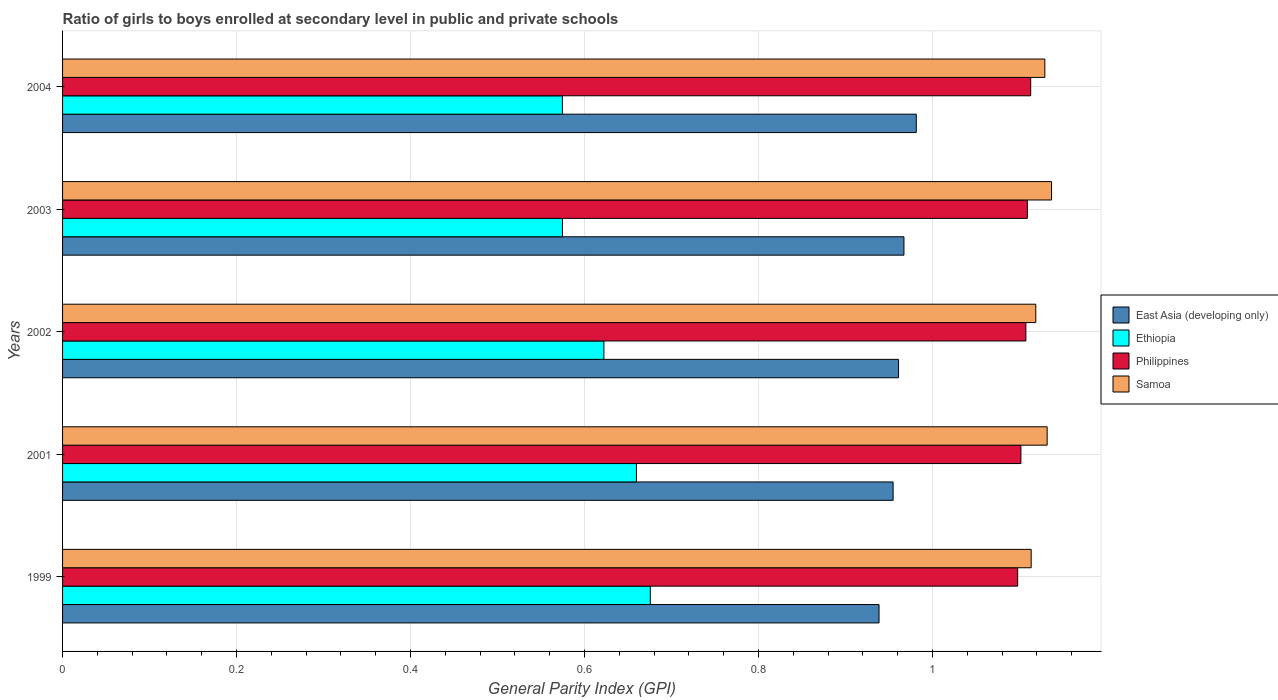Are the number of bars per tick equal to the number of legend labels?
Provide a short and direct response. Yes. How many bars are there on the 3rd tick from the top?
Give a very brief answer. 4. How many bars are there on the 5th tick from the bottom?
Make the answer very short. 4. What is the general parity index in Philippines in 2001?
Provide a short and direct response. 1.1. Across all years, what is the maximum general parity index in East Asia (developing only)?
Give a very brief answer. 0.98. Across all years, what is the minimum general parity index in Samoa?
Offer a very short reply. 1.11. In which year was the general parity index in Samoa maximum?
Make the answer very short. 2003. In which year was the general parity index in Philippines minimum?
Ensure brevity in your answer.  1999. What is the total general parity index in East Asia (developing only) in the graph?
Your answer should be compact. 4.8. What is the difference between the general parity index in Philippines in 1999 and that in 2002?
Your answer should be compact. -0.01. What is the difference between the general parity index in Ethiopia in 2004 and the general parity index in Samoa in 1999?
Make the answer very short. -0.54. What is the average general parity index in Ethiopia per year?
Provide a succinct answer. 0.62. In the year 2003, what is the difference between the general parity index in East Asia (developing only) and general parity index in Philippines?
Provide a short and direct response. -0.14. What is the ratio of the general parity index in Ethiopia in 2002 to that in 2003?
Your answer should be compact. 1.08. What is the difference between the highest and the second highest general parity index in East Asia (developing only)?
Make the answer very short. 0.01. What is the difference between the highest and the lowest general parity index in East Asia (developing only)?
Offer a very short reply. 0.04. In how many years, is the general parity index in East Asia (developing only) greater than the average general parity index in East Asia (developing only) taken over all years?
Your answer should be compact. 3. Is the sum of the general parity index in Samoa in 2003 and 2004 greater than the maximum general parity index in Ethiopia across all years?
Provide a succinct answer. Yes. Is it the case that in every year, the sum of the general parity index in Ethiopia and general parity index in Samoa is greater than the sum of general parity index in Philippines and general parity index in East Asia (developing only)?
Offer a very short reply. No. What does the 3rd bar from the top in 2002 represents?
Offer a terse response. Ethiopia. What does the 2nd bar from the bottom in 2002 represents?
Offer a terse response. Ethiopia. Is it the case that in every year, the sum of the general parity index in Ethiopia and general parity index in Philippines is greater than the general parity index in Samoa?
Provide a succinct answer. Yes. How many years are there in the graph?
Keep it short and to the point. 5. Are the values on the major ticks of X-axis written in scientific E-notation?
Keep it short and to the point. No. Does the graph contain any zero values?
Offer a terse response. No. How many legend labels are there?
Offer a very short reply. 4. How are the legend labels stacked?
Make the answer very short. Vertical. What is the title of the graph?
Give a very brief answer. Ratio of girls to boys enrolled at secondary level in public and private schools. Does "Heavily indebted poor countries" appear as one of the legend labels in the graph?
Provide a succinct answer. No. What is the label or title of the X-axis?
Give a very brief answer. General Parity Index (GPI). What is the General Parity Index (GPI) in East Asia (developing only) in 1999?
Provide a succinct answer. 0.94. What is the General Parity Index (GPI) in Ethiopia in 1999?
Offer a very short reply. 0.68. What is the General Parity Index (GPI) in Philippines in 1999?
Offer a terse response. 1.1. What is the General Parity Index (GPI) of Samoa in 1999?
Keep it short and to the point. 1.11. What is the General Parity Index (GPI) in East Asia (developing only) in 2001?
Give a very brief answer. 0.95. What is the General Parity Index (GPI) of Ethiopia in 2001?
Ensure brevity in your answer.  0.66. What is the General Parity Index (GPI) of Philippines in 2001?
Provide a short and direct response. 1.1. What is the General Parity Index (GPI) in Samoa in 2001?
Your answer should be very brief. 1.13. What is the General Parity Index (GPI) in East Asia (developing only) in 2002?
Keep it short and to the point. 0.96. What is the General Parity Index (GPI) of Ethiopia in 2002?
Offer a very short reply. 0.62. What is the General Parity Index (GPI) in Philippines in 2002?
Offer a terse response. 1.11. What is the General Parity Index (GPI) in Samoa in 2002?
Provide a succinct answer. 1.12. What is the General Parity Index (GPI) of East Asia (developing only) in 2003?
Keep it short and to the point. 0.97. What is the General Parity Index (GPI) of Ethiopia in 2003?
Give a very brief answer. 0.57. What is the General Parity Index (GPI) of Philippines in 2003?
Offer a terse response. 1.11. What is the General Parity Index (GPI) in Samoa in 2003?
Provide a succinct answer. 1.14. What is the General Parity Index (GPI) in East Asia (developing only) in 2004?
Your answer should be very brief. 0.98. What is the General Parity Index (GPI) in Ethiopia in 2004?
Ensure brevity in your answer.  0.57. What is the General Parity Index (GPI) of Philippines in 2004?
Provide a short and direct response. 1.11. What is the General Parity Index (GPI) of Samoa in 2004?
Give a very brief answer. 1.13. Across all years, what is the maximum General Parity Index (GPI) in East Asia (developing only)?
Your answer should be compact. 0.98. Across all years, what is the maximum General Parity Index (GPI) in Ethiopia?
Your answer should be compact. 0.68. Across all years, what is the maximum General Parity Index (GPI) of Philippines?
Make the answer very short. 1.11. Across all years, what is the maximum General Parity Index (GPI) in Samoa?
Ensure brevity in your answer.  1.14. Across all years, what is the minimum General Parity Index (GPI) of East Asia (developing only)?
Give a very brief answer. 0.94. Across all years, what is the minimum General Parity Index (GPI) of Ethiopia?
Offer a terse response. 0.57. Across all years, what is the minimum General Parity Index (GPI) in Philippines?
Your response must be concise. 1.1. Across all years, what is the minimum General Parity Index (GPI) of Samoa?
Offer a terse response. 1.11. What is the total General Parity Index (GPI) in East Asia (developing only) in the graph?
Give a very brief answer. 4.8. What is the total General Parity Index (GPI) in Ethiopia in the graph?
Give a very brief answer. 3.11. What is the total General Parity Index (GPI) in Philippines in the graph?
Offer a very short reply. 5.53. What is the total General Parity Index (GPI) in Samoa in the graph?
Offer a terse response. 5.63. What is the difference between the General Parity Index (GPI) in East Asia (developing only) in 1999 and that in 2001?
Provide a short and direct response. -0.02. What is the difference between the General Parity Index (GPI) in Ethiopia in 1999 and that in 2001?
Offer a very short reply. 0.02. What is the difference between the General Parity Index (GPI) of Philippines in 1999 and that in 2001?
Keep it short and to the point. -0. What is the difference between the General Parity Index (GPI) in Samoa in 1999 and that in 2001?
Your response must be concise. -0.02. What is the difference between the General Parity Index (GPI) of East Asia (developing only) in 1999 and that in 2002?
Your response must be concise. -0.02. What is the difference between the General Parity Index (GPI) of Ethiopia in 1999 and that in 2002?
Offer a very short reply. 0.05. What is the difference between the General Parity Index (GPI) in Philippines in 1999 and that in 2002?
Provide a succinct answer. -0.01. What is the difference between the General Parity Index (GPI) in Samoa in 1999 and that in 2002?
Give a very brief answer. -0.01. What is the difference between the General Parity Index (GPI) of East Asia (developing only) in 1999 and that in 2003?
Your answer should be very brief. -0.03. What is the difference between the General Parity Index (GPI) of Ethiopia in 1999 and that in 2003?
Offer a terse response. 0.1. What is the difference between the General Parity Index (GPI) of Philippines in 1999 and that in 2003?
Your response must be concise. -0.01. What is the difference between the General Parity Index (GPI) of Samoa in 1999 and that in 2003?
Make the answer very short. -0.02. What is the difference between the General Parity Index (GPI) in East Asia (developing only) in 1999 and that in 2004?
Ensure brevity in your answer.  -0.04. What is the difference between the General Parity Index (GPI) in Ethiopia in 1999 and that in 2004?
Provide a succinct answer. 0.1. What is the difference between the General Parity Index (GPI) of Philippines in 1999 and that in 2004?
Keep it short and to the point. -0.01. What is the difference between the General Parity Index (GPI) of Samoa in 1999 and that in 2004?
Ensure brevity in your answer.  -0.02. What is the difference between the General Parity Index (GPI) of East Asia (developing only) in 2001 and that in 2002?
Make the answer very short. -0.01. What is the difference between the General Parity Index (GPI) of Ethiopia in 2001 and that in 2002?
Make the answer very short. 0.04. What is the difference between the General Parity Index (GPI) of Philippines in 2001 and that in 2002?
Your answer should be very brief. -0.01. What is the difference between the General Parity Index (GPI) in Samoa in 2001 and that in 2002?
Your answer should be very brief. 0.01. What is the difference between the General Parity Index (GPI) of East Asia (developing only) in 2001 and that in 2003?
Ensure brevity in your answer.  -0.01. What is the difference between the General Parity Index (GPI) in Ethiopia in 2001 and that in 2003?
Offer a terse response. 0.09. What is the difference between the General Parity Index (GPI) in Philippines in 2001 and that in 2003?
Provide a short and direct response. -0.01. What is the difference between the General Parity Index (GPI) in Samoa in 2001 and that in 2003?
Offer a terse response. -0.01. What is the difference between the General Parity Index (GPI) in East Asia (developing only) in 2001 and that in 2004?
Provide a short and direct response. -0.03. What is the difference between the General Parity Index (GPI) of Ethiopia in 2001 and that in 2004?
Ensure brevity in your answer.  0.09. What is the difference between the General Parity Index (GPI) of Philippines in 2001 and that in 2004?
Keep it short and to the point. -0.01. What is the difference between the General Parity Index (GPI) in Samoa in 2001 and that in 2004?
Provide a succinct answer. 0. What is the difference between the General Parity Index (GPI) in East Asia (developing only) in 2002 and that in 2003?
Make the answer very short. -0.01. What is the difference between the General Parity Index (GPI) in Ethiopia in 2002 and that in 2003?
Keep it short and to the point. 0.05. What is the difference between the General Parity Index (GPI) in Philippines in 2002 and that in 2003?
Make the answer very short. -0. What is the difference between the General Parity Index (GPI) in Samoa in 2002 and that in 2003?
Your response must be concise. -0.02. What is the difference between the General Parity Index (GPI) in East Asia (developing only) in 2002 and that in 2004?
Provide a short and direct response. -0.02. What is the difference between the General Parity Index (GPI) in Ethiopia in 2002 and that in 2004?
Offer a very short reply. 0.05. What is the difference between the General Parity Index (GPI) of Philippines in 2002 and that in 2004?
Your response must be concise. -0.01. What is the difference between the General Parity Index (GPI) of Samoa in 2002 and that in 2004?
Keep it short and to the point. -0.01. What is the difference between the General Parity Index (GPI) in East Asia (developing only) in 2003 and that in 2004?
Make the answer very short. -0.01. What is the difference between the General Parity Index (GPI) of Ethiopia in 2003 and that in 2004?
Your response must be concise. 0. What is the difference between the General Parity Index (GPI) of Philippines in 2003 and that in 2004?
Offer a very short reply. -0. What is the difference between the General Parity Index (GPI) of Samoa in 2003 and that in 2004?
Your response must be concise. 0.01. What is the difference between the General Parity Index (GPI) of East Asia (developing only) in 1999 and the General Parity Index (GPI) of Ethiopia in 2001?
Ensure brevity in your answer.  0.28. What is the difference between the General Parity Index (GPI) of East Asia (developing only) in 1999 and the General Parity Index (GPI) of Philippines in 2001?
Your response must be concise. -0.16. What is the difference between the General Parity Index (GPI) of East Asia (developing only) in 1999 and the General Parity Index (GPI) of Samoa in 2001?
Ensure brevity in your answer.  -0.19. What is the difference between the General Parity Index (GPI) of Ethiopia in 1999 and the General Parity Index (GPI) of Philippines in 2001?
Make the answer very short. -0.43. What is the difference between the General Parity Index (GPI) of Ethiopia in 1999 and the General Parity Index (GPI) of Samoa in 2001?
Provide a succinct answer. -0.46. What is the difference between the General Parity Index (GPI) of Philippines in 1999 and the General Parity Index (GPI) of Samoa in 2001?
Provide a short and direct response. -0.03. What is the difference between the General Parity Index (GPI) in East Asia (developing only) in 1999 and the General Parity Index (GPI) in Ethiopia in 2002?
Provide a succinct answer. 0.32. What is the difference between the General Parity Index (GPI) in East Asia (developing only) in 1999 and the General Parity Index (GPI) in Philippines in 2002?
Make the answer very short. -0.17. What is the difference between the General Parity Index (GPI) in East Asia (developing only) in 1999 and the General Parity Index (GPI) in Samoa in 2002?
Your answer should be very brief. -0.18. What is the difference between the General Parity Index (GPI) in Ethiopia in 1999 and the General Parity Index (GPI) in Philippines in 2002?
Offer a very short reply. -0.43. What is the difference between the General Parity Index (GPI) in Ethiopia in 1999 and the General Parity Index (GPI) in Samoa in 2002?
Make the answer very short. -0.44. What is the difference between the General Parity Index (GPI) in Philippines in 1999 and the General Parity Index (GPI) in Samoa in 2002?
Give a very brief answer. -0.02. What is the difference between the General Parity Index (GPI) of East Asia (developing only) in 1999 and the General Parity Index (GPI) of Ethiopia in 2003?
Ensure brevity in your answer.  0.36. What is the difference between the General Parity Index (GPI) of East Asia (developing only) in 1999 and the General Parity Index (GPI) of Philippines in 2003?
Give a very brief answer. -0.17. What is the difference between the General Parity Index (GPI) of East Asia (developing only) in 1999 and the General Parity Index (GPI) of Samoa in 2003?
Your answer should be very brief. -0.2. What is the difference between the General Parity Index (GPI) of Ethiopia in 1999 and the General Parity Index (GPI) of Philippines in 2003?
Make the answer very short. -0.43. What is the difference between the General Parity Index (GPI) in Ethiopia in 1999 and the General Parity Index (GPI) in Samoa in 2003?
Ensure brevity in your answer.  -0.46. What is the difference between the General Parity Index (GPI) in Philippines in 1999 and the General Parity Index (GPI) in Samoa in 2003?
Make the answer very short. -0.04. What is the difference between the General Parity Index (GPI) of East Asia (developing only) in 1999 and the General Parity Index (GPI) of Ethiopia in 2004?
Your answer should be very brief. 0.36. What is the difference between the General Parity Index (GPI) in East Asia (developing only) in 1999 and the General Parity Index (GPI) in Philippines in 2004?
Your answer should be very brief. -0.17. What is the difference between the General Parity Index (GPI) of East Asia (developing only) in 1999 and the General Parity Index (GPI) of Samoa in 2004?
Offer a very short reply. -0.19. What is the difference between the General Parity Index (GPI) of Ethiopia in 1999 and the General Parity Index (GPI) of Philippines in 2004?
Offer a terse response. -0.44. What is the difference between the General Parity Index (GPI) of Ethiopia in 1999 and the General Parity Index (GPI) of Samoa in 2004?
Give a very brief answer. -0.45. What is the difference between the General Parity Index (GPI) in Philippines in 1999 and the General Parity Index (GPI) in Samoa in 2004?
Your response must be concise. -0.03. What is the difference between the General Parity Index (GPI) of East Asia (developing only) in 2001 and the General Parity Index (GPI) of Ethiopia in 2002?
Provide a succinct answer. 0.33. What is the difference between the General Parity Index (GPI) of East Asia (developing only) in 2001 and the General Parity Index (GPI) of Philippines in 2002?
Ensure brevity in your answer.  -0.15. What is the difference between the General Parity Index (GPI) of East Asia (developing only) in 2001 and the General Parity Index (GPI) of Samoa in 2002?
Offer a terse response. -0.16. What is the difference between the General Parity Index (GPI) of Ethiopia in 2001 and the General Parity Index (GPI) of Philippines in 2002?
Provide a short and direct response. -0.45. What is the difference between the General Parity Index (GPI) of Ethiopia in 2001 and the General Parity Index (GPI) of Samoa in 2002?
Ensure brevity in your answer.  -0.46. What is the difference between the General Parity Index (GPI) of Philippines in 2001 and the General Parity Index (GPI) of Samoa in 2002?
Give a very brief answer. -0.02. What is the difference between the General Parity Index (GPI) in East Asia (developing only) in 2001 and the General Parity Index (GPI) in Ethiopia in 2003?
Give a very brief answer. 0.38. What is the difference between the General Parity Index (GPI) in East Asia (developing only) in 2001 and the General Parity Index (GPI) in Philippines in 2003?
Ensure brevity in your answer.  -0.15. What is the difference between the General Parity Index (GPI) of East Asia (developing only) in 2001 and the General Parity Index (GPI) of Samoa in 2003?
Your answer should be compact. -0.18. What is the difference between the General Parity Index (GPI) in Ethiopia in 2001 and the General Parity Index (GPI) in Philippines in 2003?
Offer a very short reply. -0.45. What is the difference between the General Parity Index (GPI) in Ethiopia in 2001 and the General Parity Index (GPI) in Samoa in 2003?
Ensure brevity in your answer.  -0.48. What is the difference between the General Parity Index (GPI) in Philippines in 2001 and the General Parity Index (GPI) in Samoa in 2003?
Offer a terse response. -0.04. What is the difference between the General Parity Index (GPI) in East Asia (developing only) in 2001 and the General Parity Index (GPI) in Ethiopia in 2004?
Offer a terse response. 0.38. What is the difference between the General Parity Index (GPI) of East Asia (developing only) in 2001 and the General Parity Index (GPI) of Philippines in 2004?
Your response must be concise. -0.16. What is the difference between the General Parity Index (GPI) in East Asia (developing only) in 2001 and the General Parity Index (GPI) in Samoa in 2004?
Give a very brief answer. -0.17. What is the difference between the General Parity Index (GPI) of Ethiopia in 2001 and the General Parity Index (GPI) of Philippines in 2004?
Provide a succinct answer. -0.45. What is the difference between the General Parity Index (GPI) in Ethiopia in 2001 and the General Parity Index (GPI) in Samoa in 2004?
Your answer should be compact. -0.47. What is the difference between the General Parity Index (GPI) in Philippines in 2001 and the General Parity Index (GPI) in Samoa in 2004?
Ensure brevity in your answer.  -0.03. What is the difference between the General Parity Index (GPI) of East Asia (developing only) in 2002 and the General Parity Index (GPI) of Ethiopia in 2003?
Make the answer very short. 0.39. What is the difference between the General Parity Index (GPI) in East Asia (developing only) in 2002 and the General Parity Index (GPI) in Philippines in 2003?
Keep it short and to the point. -0.15. What is the difference between the General Parity Index (GPI) of East Asia (developing only) in 2002 and the General Parity Index (GPI) of Samoa in 2003?
Give a very brief answer. -0.18. What is the difference between the General Parity Index (GPI) in Ethiopia in 2002 and the General Parity Index (GPI) in Philippines in 2003?
Ensure brevity in your answer.  -0.49. What is the difference between the General Parity Index (GPI) of Ethiopia in 2002 and the General Parity Index (GPI) of Samoa in 2003?
Keep it short and to the point. -0.51. What is the difference between the General Parity Index (GPI) of Philippines in 2002 and the General Parity Index (GPI) of Samoa in 2003?
Your response must be concise. -0.03. What is the difference between the General Parity Index (GPI) in East Asia (developing only) in 2002 and the General Parity Index (GPI) in Ethiopia in 2004?
Keep it short and to the point. 0.39. What is the difference between the General Parity Index (GPI) of East Asia (developing only) in 2002 and the General Parity Index (GPI) of Philippines in 2004?
Give a very brief answer. -0.15. What is the difference between the General Parity Index (GPI) in East Asia (developing only) in 2002 and the General Parity Index (GPI) in Samoa in 2004?
Make the answer very short. -0.17. What is the difference between the General Parity Index (GPI) in Ethiopia in 2002 and the General Parity Index (GPI) in Philippines in 2004?
Ensure brevity in your answer.  -0.49. What is the difference between the General Parity Index (GPI) of Ethiopia in 2002 and the General Parity Index (GPI) of Samoa in 2004?
Your answer should be very brief. -0.51. What is the difference between the General Parity Index (GPI) in Philippines in 2002 and the General Parity Index (GPI) in Samoa in 2004?
Make the answer very short. -0.02. What is the difference between the General Parity Index (GPI) in East Asia (developing only) in 2003 and the General Parity Index (GPI) in Ethiopia in 2004?
Make the answer very short. 0.39. What is the difference between the General Parity Index (GPI) in East Asia (developing only) in 2003 and the General Parity Index (GPI) in Philippines in 2004?
Your answer should be very brief. -0.15. What is the difference between the General Parity Index (GPI) in East Asia (developing only) in 2003 and the General Parity Index (GPI) in Samoa in 2004?
Your answer should be compact. -0.16. What is the difference between the General Parity Index (GPI) in Ethiopia in 2003 and the General Parity Index (GPI) in Philippines in 2004?
Your answer should be compact. -0.54. What is the difference between the General Parity Index (GPI) in Ethiopia in 2003 and the General Parity Index (GPI) in Samoa in 2004?
Ensure brevity in your answer.  -0.55. What is the difference between the General Parity Index (GPI) in Philippines in 2003 and the General Parity Index (GPI) in Samoa in 2004?
Provide a succinct answer. -0.02. What is the average General Parity Index (GPI) of East Asia (developing only) per year?
Offer a very short reply. 0.96. What is the average General Parity Index (GPI) of Ethiopia per year?
Offer a terse response. 0.62. What is the average General Parity Index (GPI) of Philippines per year?
Make the answer very short. 1.11. What is the average General Parity Index (GPI) in Samoa per year?
Provide a short and direct response. 1.13. In the year 1999, what is the difference between the General Parity Index (GPI) of East Asia (developing only) and General Parity Index (GPI) of Ethiopia?
Your answer should be very brief. 0.26. In the year 1999, what is the difference between the General Parity Index (GPI) of East Asia (developing only) and General Parity Index (GPI) of Philippines?
Give a very brief answer. -0.16. In the year 1999, what is the difference between the General Parity Index (GPI) in East Asia (developing only) and General Parity Index (GPI) in Samoa?
Your answer should be compact. -0.17. In the year 1999, what is the difference between the General Parity Index (GPI) in Ethiopia and General Parity Index (GPI) in Philippines?
Keep it short and to the point. -0.42. In the year 1999, what is the difference between the General Parity Index (GPI) of Ethiopia and General Parity Index (GPI) of Samoa?
Your answer should be compact. -0.44. In the year 1999, what is the difference between the General Parity Index (GPI) in Philippines and General Parity Index (GPI) in Samoa?
Make the answer very short. -0.02. In the year 2001, what is the difference between the General Parity Index (GPI) in East Asia (developing only) and General Parity Index (GPI) in Ethiopia?
Offer a terse response. 0.3. In the year 2001, what is the difference between the General Parity Index (GPI) in East Asia (developing only) and General Parity Index (GPI) in Philippines?
Keep it short and to the point. -0.15. In the year 2001, what is the difference between the General Parity Index (GPI) in East Asia (developing only) and General Parity Index (GPI) in Samoa?
Your answer should be very brief. -0.18. In the year 2001, what is the difference between the General Parity Index (GPI) in Ethiopia and General Parity Index (GPI) in Philippines?
Your answer should be very brief. -0.44. In the year 2001, what is the difference between the General Parity Index (GPI) of Ethiopia and General Parity Index (GPI) of Samoa?
Provide a succinct answer. -0.47. In the year 2001, what is the difference between the General Parity Index (GPI) in Philippines and General Parity Index (GPI) in Samoa?
Offer a terse response. -0.03. In the year 2002, what is the difference between the General Parity Index (GPI) in East Asia (developing only) and General Parity Index (GPI) in Ethiopia?
Keep it short and to the point. 0.34. In the year 2002, what is the difference between the General Parity Index (GPI) in East Asia (developing only) and General Parity Index (GPI) in Philippines?
Your answer should be compact. -0.15. In the year 2002, what is the difference between the General Parity Index (GPI) in East Asia (developing only) and General Parity Index (GPI) in Samoa?
Make the answer very short. -0.16. In the year 2002, what is the difference between the General Parity Index (GPI) of Ethiopia and General Parity Index (GPI) of Philippines?
Give a very brief answer. -0.49. In the year 2002, what is the difference between the General Parity Index (GPI) in Ethiopia and General Parity Index (GPI) in Samoa?
Ensure brevity in your answer.  -0.5. In the year 2002, what is the difference between the General Parity Index (GPI) of Philippines and General Parity Index (GPI) of Samoa?
Make the answer very short. -0.01. In the year 2003, what is the difference between the General Parity Index (GPI) in East Asia (developing only) and General Parity Index (GPI) in Ethiopia?
Provide a succinct answer. 0.39. In the year 2003, what is the difference between the General Parity Index (GPI) of East Asia (developing only) and General Parity Index (GPI) of Philippines?
Make the answer very short. -0.14. In the year 2003, what is the difference between the General Parity Index (GPI) of East Asia (developing only) and General Parity Index (GPI) of Samoa?
Provide a short and direct response. -0.17. In the year 2003, what is the difference between the General Parity Index (GPI) in Ethiopia and General Parity Index (GPI) in Philippines?
Ensure brevity in your answer.  -0.53. In the year 2003, what is the difference between the General Parity Index (GPI) of Ethiopia and General Parity Index (GPI) of Samoa?
Offer a very short reply. -0.56. In the year 2003, what is the difference between the General Parity Index (GPI) of Philippines and General Parity Index (GPI) of Samoa?
Provide a succinct answer. -0.03. In the year 2004, what is the difference between the General Parity Index (GPI) in East Asia (developing only) and General Parity Index (GPI) in Ethiopia?
Keep it short and to the point. 0.41. In the year 2004, what is the difference between the General Parity Index (GPI) in East Asia (developing only) and General Parity Index (GPI) in Philippines?
Your answer should be compact. -0.13. In the year 2004, what is the difference between the General Parity Index (GPI) in East Asia (developing only) and General Parity Index (GPI) in Samoa?
Your answer should be very brief. -0.15. In the year 2004, what is the difference between the General Parity Index (GPI) of Ethiopia and General Parity Index (GPI) of Philippines?
Offer a terse response. -0.54. In the year 2004, what is the difference between the General Parity Index (GPI) of Ethiopia and General Parity Index (GPI) of Samoa?
Offer a terse response. -0.55. In the year 2004, what is the difference between the General Parity Index (GPI) in Philippines and General Parity Index (GPI) in Samoa?
Ensure brevity in your answer.  -0.02. What is the ratio of the General Parity Index (GPI) in East Asia (developing only) in 1999 to that in 2001?
Ensure brevity in your answer.  0.98. What is the ratio of the General Parity Index (GPI) in Ethiopia in 1999 to that in 2001?
Ensure brevity in your answer.  1.02. What is the ratio of the General Parity Index (GPI) of Philippines in 1999 to that in 2001?
Make the answer very short. 1. What is the ratio of the General Parity Index (GPI) of Samoa in 1999 to that in 2001?
Your response must be concise. 0.98. What is the ratio of the General Parity Index (GPI) of East Asia (developing only) in 1999 to that in 2002?
Your answer should be very brief. 0.98. What is the ratio of the General Parity Index (GPI) of Ethiopia in 1999 to that in 2002?
Your response must be concise. 1.09. What is the ratio of the General Parity Index (GPI) in Samoa in 1999 to that in 2002?
Provide a short and direct response. 1. What is the ratio of the General Parity Index (GPI) of East Asia (developing only) in 1999 to that in 2003?
Ensure brevity in your answer.  0.97. What is the ratio of the General Parity Index (GPI) of Ethiopia in 1999 to that in 2003?
Give a very brief answer. 1.18. What is the ratio of the General Parity Index (GPI) of Philippines in 1999 to that in 2003?
Your response must be concise. 0.99. What is the ratio of the General Parity Index (GPI) of Samoa in 1999 to that in 2003?
Your answer should be very brief. 0.98. What is the ratio of the General Parity Index (GPI) in East Asia (developing only) in 1999 to that in 2004?
Provide a succinct answer. 0.96. What is the ratio of the General Parity Index (GPI) of Ethiopia in 1999 to that in 2004?
Provide a short and direct response. 1.18. What is the ratio of the General Parity Index (GPI) of Philippines in 1999 to that in 2004?
Keep it short and to the point. 0.99. What is the ratio of the General Parity Index (GPI) in Samoa in 1999 to that in 2004?
Offer a very short reply. 0.99. What is the ratio of the General Parity Index (GPI) in Ethiopia in 2001 to that in 2002?
Your answer should be compact. 1.06. What is the ratio of the General Parity Index (GPI) of Philippines in 2001 to that in 2002?
Your response must be concise. 0.99. What is the ratio of the General Parity Index (GPI) in Samoa in 2001 to that in 2002?
Give a very brief answer. 1.01. What is the ratio of the General Parity Index (GPI) in East Asia (developing only) in 2001 to that in 2003?
Your answer should be very brief. 0.99. What is the ratio of the General Parity Index (GPI) of Ethiopia in 2001 to that in 2003?
Provide a short and direct response. 1.15. What is the ratio of the General Parity Index (GPI) of Samoa in 2001 to that in 2003?
Ensure brevity in your answer.  1. What is the ratio of the General Parity Index (GPI) in East Asia (developing only) in 2001 to that in 2004?
Your answer should be very brief. 0.97. What is the ratio of the General Parity Index (GPI) of Ethiopia in 2001 to that in 2004?
Offer a very short reply. 1.15. What is the ratio of the General Parity Index (GPI) in Philippines in 2001 to that in 2004?
Offer a terse response. 0.99. What is the ratio of the General Parity Index (GPI) of East Asia (developing only) in 2002 to that in 2003?
Offer a terse response. 0.99. What is the ratio of the General Parity Index (GPI) of Ethiopia in 2002 to that in 2003?
Your answer should be very brief. 1.08. What is the ratio of the General Parity Index (GPI) of Philippines in 2002 to that in 2003?
Offer a terse response. 1. What is the ratio of the General Parity Index (GPI) in Samoa in 2002 to that in 2003?
Provide a succinct answer. 0.98. What is the ratio of the General Parity Index (GPI) of East Asia (developing only) in 2002 to that in 2004?
Your answer should be very brief. 0.98. What is the ratio of the General Parity Index (GPI) in Ethiopia in 2002 to that in 2004?
Offer a terse response. 1.08. What is the ratio of the General Parity Index (GPI) in Philippines in 2002 to that in 2004?
Offer a terse response. 0.99. What is the ratio of the General Parity Index (GPI) of East Asia (developing only) in 2003 to that in 2004?
Offer a very short reply. 0.99. What is the ratio of the General Parity Index (GPI) in Ethiopia in 2003 to that in 2004?
Offer a terse response. 1. What is the ratio of the General Parity Index (GPI) in Samoa in 2003 to that in 2004?
Ensure brevity in your answer.  1.01. What is the difference between the highest and the second highest General Parity Index (GPI) of East Asia (developing only)?
Provide a short and direct response. 0.01. What is the difference between the highest and the second highest General Parity Index (GPI) in Ethiopia?
Your answer should be compact. 0.02. What is the difference between the highest and the second highest General Parity Index (GPI) in Philippines?
Your answer should be very brief. 0. What is the difference between the highest and the second highest General Parity Index (GPI) of Samoa?
Provide a succinct answer. 0.01. What is the difference between the highest and the lowest General Parity Index (GPI) of East Asia (developing only)?
Offer a terse response. 0.04. What is the difference between the highest and the lowest General Parity Index (GPI) in Ethiopia?
Provide a succinct answer. 0.1. What is the difference between the highest and the lowest General Parity Index (GPI) of Philippines?
Keep it short and to the point. 0.01. What is the difference between the highest and the lowest General Parity Index (GPI) of Samoa?
Provide a succinct answer. 0.02. 